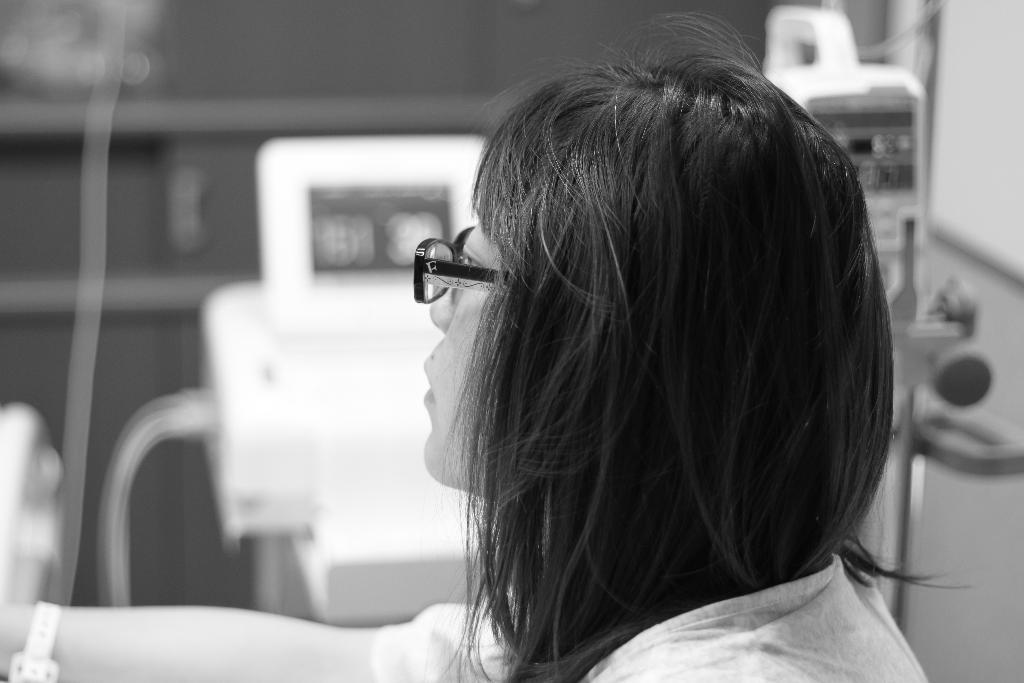Who is the main subject in the image? There is a girl in the image. Where is the girl located in the image? The girl is on the right side of the image. What can be seen in the background of the image? There is machinery in the background of the image. What type of seed is the girl planting in the image? There is no seed or planting activity present in the image; it features a girl and machinery in the background. What color is the orange tent in the image? There is no orange tent present in the image. 